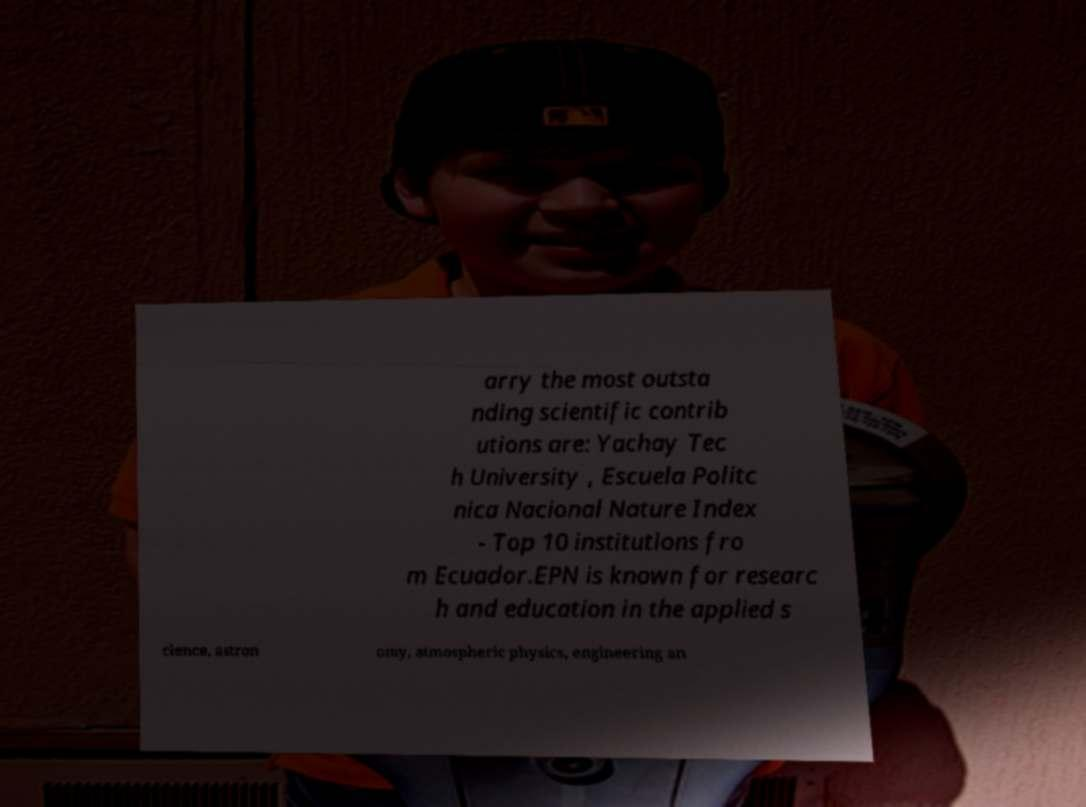What messages or text are displayed in this image? I need them in a readable, typed format. arry the most outsta nding scientific contrib utions are: Yachay Tec h University , Escuela Politc nica Nacional Nature Index - Top 10 institutions fro m Ecuador.EPN is known for researc h and education in the applied s cience, astron omy, atmospheric physics, engineering an 